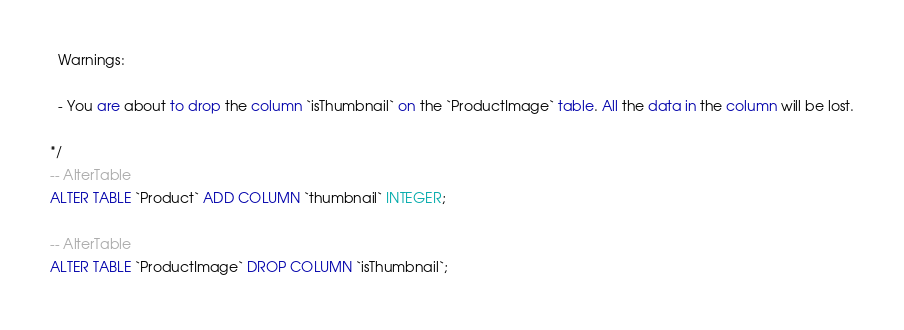Convert code to text. <code><loc_0><loc_0><loc_500><loc_500><_SQL_>  Warnings:

  - You are about to drop the column `isThumbnail` on the `ProductImage` table. All the data in the column will be lost.

*/
-- AlterTable
ALTER TABLE `Product` ADD COLUMN `thumbnail` INTEGER;

-- AlterTable
ALTER TABLE `ProductImage` DROP COLUMN `isThumbnail`;
</code> 